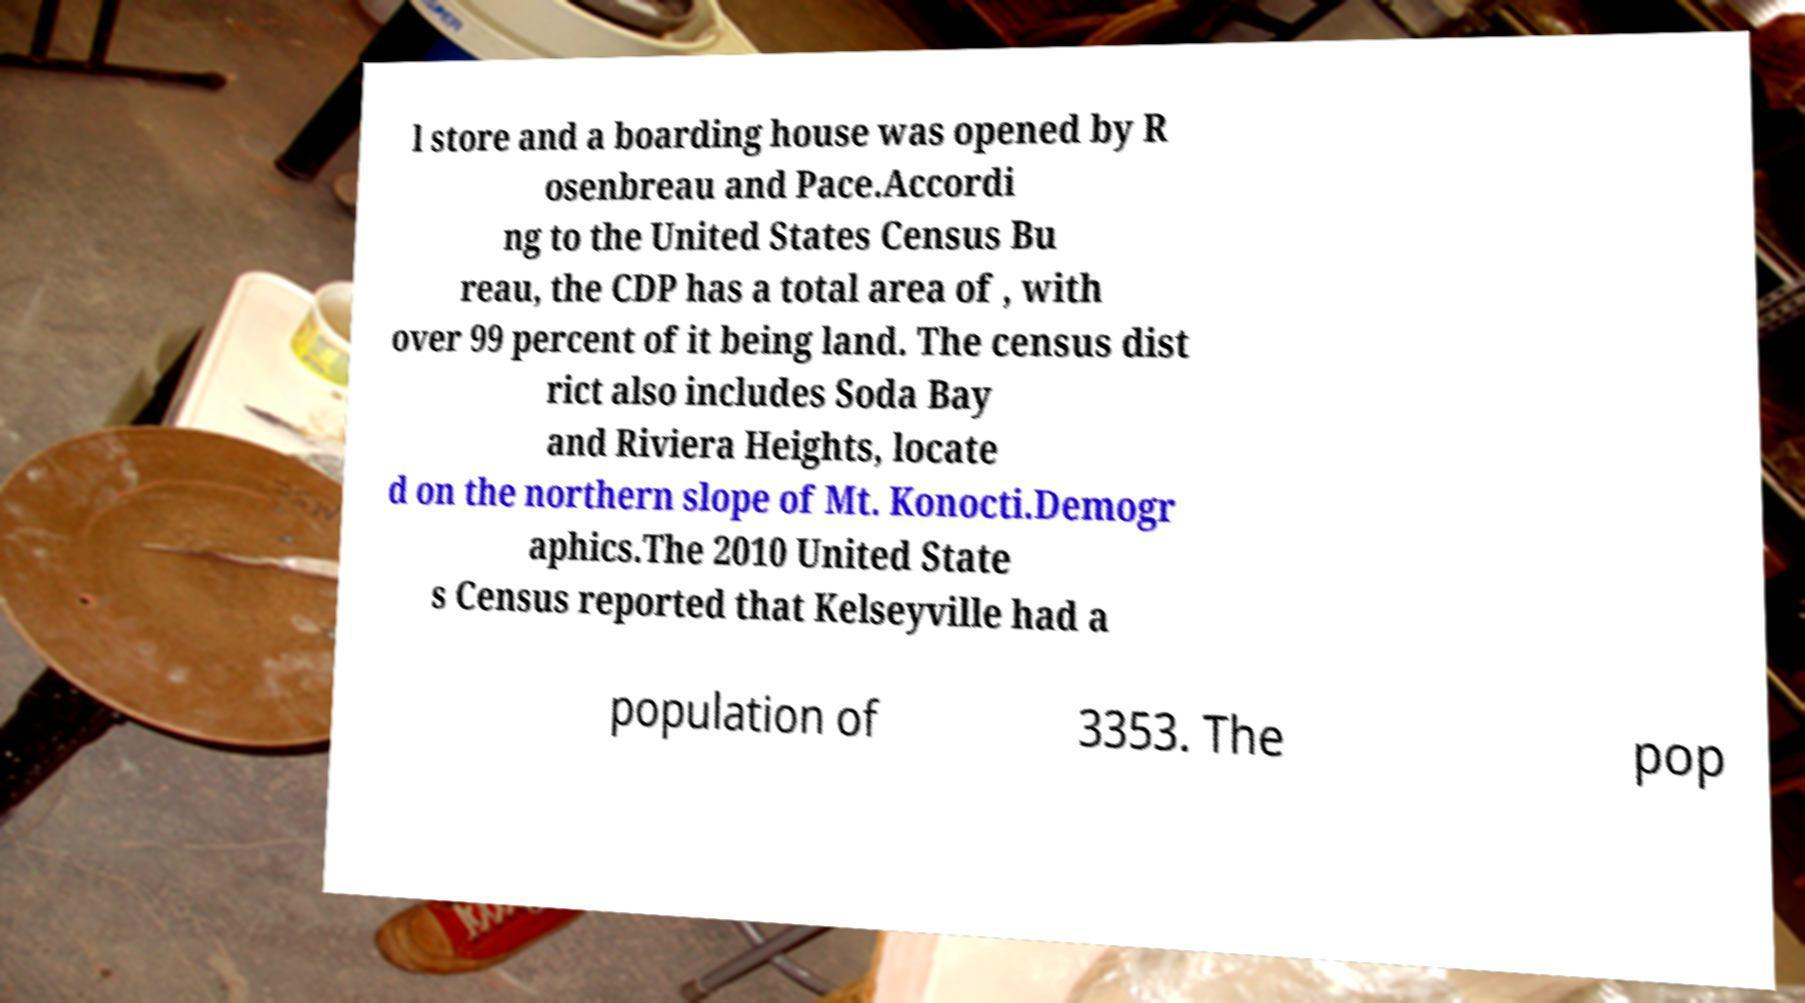Could you assist in decoding the text presented in this image and type it out clearly? l store and a boarding house was opened by R osenbreau and Pace.Accordi ng to the United States Census Bu reau, the CDP has a total area of , with over 99 percent of it being land. The census dist rict also includes Soda Bay and Riviera Heights, locate d on the northern slope of Mt. Konocti.Demogr aphics.The 2010 United State s Census reported that Kelseyville had a population of 3353. The pop 